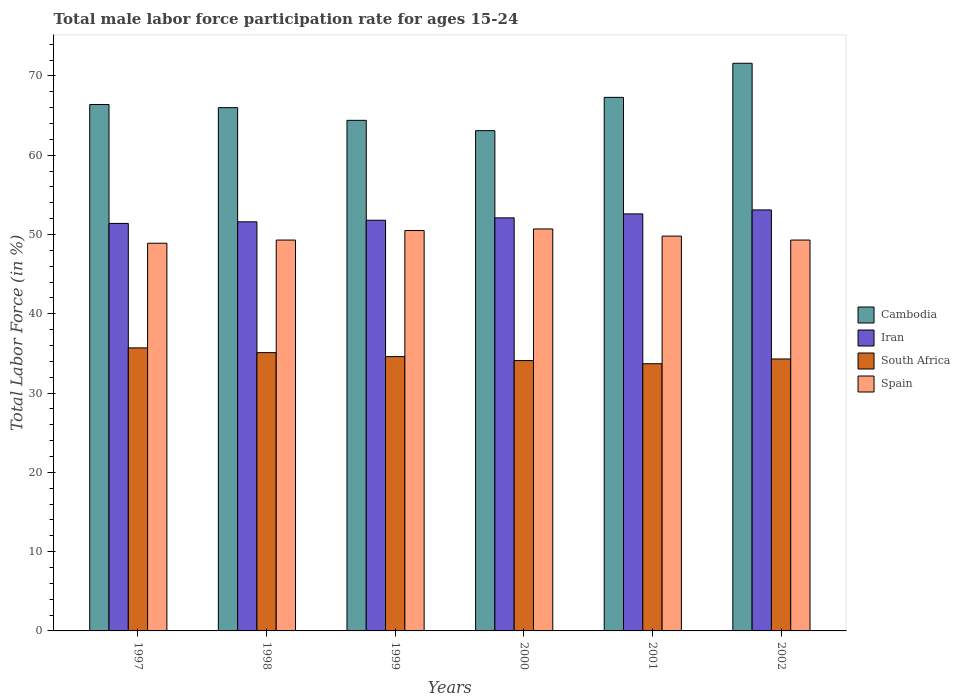How many different coloured bars are there?
Provide a short and direct response. 4. Are the number of bars on each tick of the X-axis equal?
Your answer should be very brief. Yes. How many bars are there on the 2nd tick from the left?
Your response must be concise. 4. How many bars are there on the 1st tick from the right?
Ensure brevity in your answer.  4. What is the label of the 5th group of bars from the left?
Your response must be concise. 2001. What is the male labor force participation rate in South Africa in 1997?
Your answer should be very brief. 35.7. Across all years, what is the maximum male labor force participation rate in Iran?
Provide a short and direct response. 53.1. Across all years, what is the minimum male labor force participation rate in South Africa?
Provide a short and direct response. 33.7. In which year was the male labor force participation rate in South Africa maximum?
Your response must be concise. 1997. In which year was the male labor force participation rate in Cambodia minimum?
Offer a terse response. 2000. What is the total male labor force participation rate in Spain in the graph?
Give a very brief answer. 298.5. What is the difference between the male labor force participation rate in Cambodia in 1997 and that in 2002?
Offer a very short reply. -5.2. What is the difference between the male labor force participation rate in South Africa in 2000 and the male labor force participation rate in Spain in 1998?
Make the answer very short. -15.2. What is the average male labor force participation rate in Cambodia per year?
Provide a succinct answer. 66.47. In the year 2002, what is the difference between the male labor force participation rate in South Africa and male labor force participation rate in Iran?
Your answer should be compact. -18.8. What is the ratio of the male labor force participation rate in Spain in 1999 to that in 2000?
Provide a short and direct response. 1. What is the difference between the highest and the second highest male labor force participation rate in South Africa?
Ensure brevity in your answer.  0.6. What is the difference between the highest and the lowest male labor force participation rate in Cambodia?
Give a very brief answer. 8.5. Is the sum of the male labor force participation rate in South Africa in 1998 and 2001 greater than the maximum male labor force participation rate in Spain across all years?
Offer a terse response. Yes. Is it the case that in every year, the sum of the male labor force participation rate in Spain and male labor force participation rate in Cambodia is greater than the sum of male labor force participation rate in South Africa and male labor force participation rate in Iran?
Offer a very short reply. Yes. What does the 1st bar from the left in 2001 represents?
Your response must be concise. Cambodia. What does the 2nd bar from the right in 2001 represents?
Your answer should be very brief. South Africa. Is it the case that in every year, the sum of the male labor force participation rate in Iran and male labor force participation rate in Cambodia is greater than the male labor force participation rate in Spain?
Make the answer very short. Yes. How many bars are there?
Your response must be concise. 24. How many years are there in the graph?
Ensure brevity in your answer.  6. What is the difference between two consecutive major ticks on the Y-axis?
Offer a very short reply. 10. Are the values on the major ticks of Y-axis written in scientific E-notation?
Ensure brevity in your answer.  No. Does the graph contain grids?
Ensure brevity in your answer.  No. How are the legend labels stacked?
Keep it short and to the point. Vertical. What is the title of the graph?
Provide a short and direct response. Total male labor force participation rate for ages 15-24. Does "Low income" appear as one of the legend labels in the graph?
Your answer should be compact. No. What is the Total Labor Force (in %) of Cambodia in 1997?
Give a very brief answer. 66.4. What is the Total Labor Force (in %) in Iran in 1997?
Your response must be concise. 51.4. What is the Total Labor Force (in %) of South Africa in 1997?
Offer a very short reply. 35.7. What is the Total Labor Force (in %) of Spain in 1997?
Make the answer very short. 48.9. What is the Total Labor Force (in %) of Iran in 1998?
Your response must be concise. 51.6. What is the Total Labor Force (in %) of South Africa in 1998?
Provide a short and direct response. 35.1. What is the Total Labor Force (in %) of Spain in 1998?
Your answer should be compact. 49.3. What is the Total Labor Force (in %) of Cambodia in 1999?
Provide a succinct answer. 64.4. What is the Total Labor Force (in %) of Iran in 1999?
Your answer should be very brief. 51.8. What is the Total Labor Force (in %) in South Africa in 1999?
Keep it short and to the point. 34.6. What is the Total Labor Force (in %) in Spain in 1999?
Provide a succinct answer. 50.5. What is the Total Labor Force (in %) of Cambodia in 2000?
Your answer should be compact. 63.1. What is the Total Labor Force (in %) in Iran in 2000?
Your answer should be compact. 52.1. What is the Total Labor Force (in %) of South Africa in 2000?
Ensure brevity in your answer.  34.1. What is the Total Labor Force (in %) in Spain in 2000?
Offer a very short reply. 50.7. What is the Total Labor Force (in %) in Cambodia in 2001?
Your answer should be very brief. 67.3. What is the Total Labor Force (in %) of Iran in 2001?
Your response must be concise. 52.6. What is the Total Labor Force (in %) in South Africa in 2001?
Make the answer very short. 33.7. What is the Total Labor Force (in %) of Spain in 2001?
Your answer should be compact. 49.8. What is the Total Labor Force (in %) of Cambodia in 2002?
Your response must be concise. 71.6. What is the Total Labor Force (in %) of Iran in 2002?
Keep it short and to the point. 53.1. What is the Total Labor Force (in %) in South Africa in 2002?
Make the answer very short. 34.3. What is the Total Labor Force (in %) of Spain in 2002?
Offer a terse response. 49.3. Across all years, what is the maximum Total Labor Force (in %) in Cambodia?
Your response must be concise. 71.6. Across all years, what is the maximum Total Labor Force (in %) of Iran?
Offer a terse response. 53.1. Across all years, what is the maximum Total Labor Force (in %) of South Africa?
Ensure brevity in your answer.  35.7. Across all years, what is the maximum Total Labor Force (in %) in Spain?
Give a very brief answer. 50.7. Across all years, what is the minimum Total Labor Force (in %) of Cambodia?
Ensure brevity in your answer.  63.1. Across all years, what is the minimum Total Labor Force (in %) in Iran?
Provide a short and direct response. 51.4. Across all years, what is the minimum Total Labor Force (in %) in South Africa?
Keep it short and to the point. 33.7. Across all years, what is the minimum Total Labor Force (in %) in Spain?
Ensure brevity in your answer.  48.9. What is the total Total Labor Force (in %) in Cambodia in the graph?
Your answer should be compact. 398.8. What is the total Total Labor Force (in %) in Iran in the graph?
Provide a short and direct response. 312.6. What is the total Total Labor Force (in %) in South Africa in the graph?
Offer a very short reply. 207.5. What is the total Total Labor Force (in %) of Spain in the graph?
Provide a succinct answer. 298.5. What is the difference between the Total Labor Force (in %) of Cambodia in 1997 and that in 1999?
Offer a very short reply. 2. What is the difference between the Total Labor Force (in %) of Iran in 1997 and that in 2000?
Your response must be concise. -0.7. What is the difference between the Total Labor Force (in %) of South Africa in 1997 and that in 2000?
Ensure brevity in your answer.  1.6. What is the difference between the Total Labor Force (in %) of Spain in 1997 and that in 2000?
Keep it short and to the point. -1.8. What is the difference between the Total Labor Force (in %) in Cambodia in 1997 and that in 2001?
Offer a terse response. -0.9. What is the difference between the Total Labor Force (in %) of South Africa in 1997 and that in 2001?
Your answer should be very brief. 2. What is the difference between the Total Labor Force (in %) in South Africa in 1997 and that in 2002?
Provide a short and direct response. 1.4. What is the difference between the Total Labor Force (in %) in Iran in 1998 and that in 1999?
Provide a short and direct response. -0.2. What is the difference between the Total Labor Force (in %) of South Africa in 1998 and that in 1999?
Give a very brief answer. 0.5. What is the difference between the Total Labor Force (in %) in Spain in 1998 and that in 1999?
Offer a terse response. -1.2. What is the difference between the Total Labor Force (in %) of Cambodia in 1998 and that in 2000?
Provide a short and direct response. 2.9. What is the difference between the Total Labor Force (in %) in Iran in 1998 and that in 2000?
Keep it short and to the point. -0.5. What is the difference between the Total Labor Force (in %) in Spain in 1998 and that in 2000?
Offer a very short reply. -1.4. What is the difference between the Total Labor Force (in %) in Cambodia in 1998 and that in 2001?
Your response must be concise. -1.3. What is the difference between the Total Labor Force (in %) in Cambodia in 1998 and that in 2002?
Your response must be concise. -5.6. What is the difference between the Total Labor Force (in %) in Iran in 1998 and that in 2002?
Keep it short and to the point. -1.5. What is the difference between the Total Labor Force (in %) of South Africa in 1998 and that in 2002?
Ensure brevity in your answer.  0.8. What is the difference between the Total Labor Force (in %) of Spain in 1998 and that in 2002?
Make the answer very short. 0. What is the difference between the Total Labor Force (in %) of Cambodia in 1999 and that in 2000?
Offer a very short reply. 1.3. What is the difference between the Total Labor Force (in %) of Iran in 1999 and that in 2000?
Give a very brief answer. -0.3. What is the difference between the Total Labor Force (in %) of South Africa in 1999 and that in 2000?
Provide a short and direct response. 0.5. What is the difference between the Total Labor Force (in %) of Spain in 1999 and that in 2000?
Offer a terse response. -0.2. What is the difference between the Total Labor Force (in %) of Cambodia in 1999 and that in 2001?
Keep it short and to the point. -2.9. What is the difference between the Total Labor Force (in %) of Iran in 1999 and that in 2002?
Provide a short and direct response. -1.3. What is the difference between the Total Labor Force (in %) of South Africa in 1999 and that in 2002?
Keep it short and to the point. 0.3. What is the difference between the Total Labor Force (in %) in Spain in 1999 and that in 2002?
Your response must be concise. 1.2. What is the difference between the Total Labor Force (in %) in Iran in 2000 and that in 2002?
Keep it short and to the point. -1. What is the difference between the Total Labor Force (in %) in Spain in 2000 and that in 2002?
Your answer should be very brief. 1.4. What is the difference between the Total Labor Force (in %) in Iran in 2001 and that in 2002?
Provide a succinct answer. -0.5. What is the difference between the Total Labor Force (in %) of Cambodia in 1997 and the Total Labor Force (in %) of South Africa in 1998?
Offer a very short reply. 31.3. What is the difference between the Total Labor Force (in %) in Cambodia in 1997 and the Total Labor Force (in %) in Iran in 1999?
Make the answer very short. 14.6. What is the difference between the Total Labor Force (in %) of Cambodia in 1997 and the Total Labor Force (in %) of South Africa in 1999?
Your answer should be compact. 31.8. What is the difference between the Total Labor Force (in %) of Iran in 1997 and the Total Labor Force (in %) of Spain in 1999?
Keep it short and to the point. 0.9. What is the difference between the Total Labor Force (in %) in South Africa in 1997 and the Total Labor Force (in %) in Spain in 1999?
Your response must be concise. -14.8. What is the difference between the Total Labor Force (in %) of Cambodia in 1997 and the Total Labor Force (in %) of South Africa in 2000?
Give a very brief answer. 32.3. What is the difference between the Total Labor Force (in %) in Cambodia in 1997 and the Total Labor Force (in %) in Spain in 2000?
Ensure brevity in your answer.  15.7. What is the difference between the Total Labor Force (in %) of Iran in 1997 and the Total Labor Force (in %) of South Africa in 2000?
Your answer should be very brief. 17.3. What is the difference between the Total Labor Force (in %) of South Africa in 1997 and the Total Labor Force (in %) of Spain in 2000?
Give a very brief answer. -15. What is the difference between the Total Labor Force (in %) in Cambodia in 1997 and the Total Labor Force (in %) in Iran in 2001?
Your answer should be very brief. 13.8. What is the difference between the Total Labor Force (in %) in Cambodia in 1997 and the Total Labor Force (in %) in South Africa in 2001?
Provide a succinct answer. 32.7. What is the difference between the Total Labor Force (in %) in Cambodia in 1997 and the Total Labor Force (in %) in Spain in 2001?
Your answer should be very brief. 16.6. What is the difference between the Total Labor Force (in %) of Iran in 1997 and the Total Labor Force (in %) of South Africa in 2001?
Your answer should be compact. 17.7. What is the difference between the Total Labor Force (in %) of Iran in 1997 and the Total Labor Force (in %) of Spain in 2001?
Provide a short and direct response. 1.6. What is the difference between the Total Labor Force (in %) of South Africa in 1997 and the Total Labor Force (in %) of Spain in 2001?
Your response must be concise. -14.1. What is the difference between the Total Labor Force (in %) in Cambodia in 1997 and the Total Labor Force (in %) in South Africa in 2002?
Ensure brevity in your answer.  32.1. What is the difference between the Total Labor Force (in %) in Cambodia in 1997 and the Total Labor Force (in %) in Spain in 2002?
Make the answer very short. 17.1. What is the difference between the Total Labor Force (in %) of South Africa in 1997 and the Total Labor Force (in %) of Spain in 2002?
Provide a succinct answer. -13.6. What is the difference between the Total Labor Force (in %) in Cambodia in 1998 and the Total Labor Force (in %) in Iran in 1999?
Offer a very short reply. 14.2. What is the difference between the Total Labor Force (in %) in Cambodia in 1998 and the Total Labor Force (in %) in South Africa in 1999?
Ensure brevity in your answer.  31.4. What is the difference between the Total Labor Force (in %) of Cambodia in 1998 and the Total Labor Force (in %) of Spain in 1999?
Your answer should be compact. 15.5. What is the difference between the Total Labor Force (in %) in Iran in 1998 and the Total Labor Force (in %) in South Africa in 1999?
Your answer should be compact. 17. What is the difference between the Total Labor Force (in %) of South Africa in 1998 and the Total Labor Force (in %) of Spain in 1999?
Make the answer very short. -15.4. What is the difference between the Total Labor Force (in %) in Cambodia in 1998 and the Total Labor Force (in %) in South Africa in 2000?
Provide a succinct answer. 31.9. What is the difference between the Total Labor Force (in %) in Cambodia in 1998 and the Total Labor Force (in %) in Spain in 2000?
Make the answer very short. 15.3. What is the difference between the Total Labor Force (in %) of South Africa in 1998 and the Total Labor Force (in %) of Spain in 2000?
Your response must be concise. -15.6. What is the difference between the Total Labor Force (in %) in Cambodia in 1998 and the Total Labor Force (in %) in Iran in 2001?
Provide a succinct answer. 13.4. What is the difference between the Total Labor Force (in %) in Cambodia in 1998 and the Total Labor Force (in %) in South Africa in 2001?
Offer a very short reply. 32.3. What is the difference between the Total Labor Force (in %) of Cambodia in 1998 and the Total Labor Force (in %) of Spain in 2001?
Give a very brief answer. 16.2. What is the difference between the Total Labor Force (in %) in Iran in 1998 and the Total Labor Force (in %) in Spain in 2001?
Your answer should be very brief. 1.8. What is the difference between the Total Labor Force (in %) in South Africa in 1998 and the Total Labor Force (in %) in Spain in 2001?
Keep it short and to the point. -14.7. What is the difference between the Total Labor Force (in %) in Cambodia in 1998 and the Total Labor Force (in %) in South Africa in 2002?
Your answer should be compact. 31.7. What is the difference between the Total Labor Force (in %) of Cambodia in 1998 and the Total Labor Force (in %) of Spain in 2002?
Make the answer very short. 16.7. What is the difference between the Total Labor Force (in %) in Iran in 1998 and the Total Labor Force (in %) in Spain in 2002?
Keep it short and to the point. 2.3. What is the difference between the Total Labor Force (in %) in South Africa in 1998 and the Total Labor Force (in %) in Spain in 2002?
Keep it short and to the point. -14.2. What is the difference between the Total Labor Force (in %) of Cambodia in 1999 and the Total Labor Force (in %) of Iran in 2000?
Keep it short and to the point. 12.3. What is the difference between the Total Labor Force (in %) of Cambodia in 1999 and the Total Labor Force (in %) of South Africa in 2000?
Keep it short and to the point. 30.3. What is the difference between the Total Labor Force (in %) in Iran in 1999 and the Total Labor Force (in %) in South Africa in 2000?
Keep it short and to the point. 17.7. What is the difference between the Total Labor Force (in %) in Iran in 1999 and the Total Labor Force (in %) in Spain in 2000?
Ensure brevity in your answer.  1.1. What is the difference between the Total Labor Force (in %) in South Africa in 1999 and the Total Labor Force (in %) in Spain in 2000?
Ensure brevity in your answer.  -16.1. What is the difference between the Total Labor Force (in %) in Cambodia in 1999 and the Total Labor Force (in %) in Iran in 2001?
Offer a very short reply. 11.8. What is the difference between the Total Labor Force (in %) of Cambodia in 1999 and the Total Labor Force (in %) of South Africa in 2001?
Ensure brevity in your answer.  30.7. What is the difference between the Total Labor Force (in %) of Iran in 1999 and the Total Labor Force (in %) of Spain in 2001?
Provide a succinct answer. 2. What is the difference between the Total Labor Force (in %) of South Africa in 1999 and the Total Labor Force (in %) of Spain in 2001?
Offer a terse response. -15.2. What is the difference between the Total Labor Force (in %) in Cambodia in 1999 and the Total Labor Force (in %) in Iran in 2002?
Offer a terse response. 11.3. What is the difference between the Total Labor Force (in %) of Cambodia in 1999 and the Total Labor Force (in %) of South Africa in 2002?
Your answer should be compact. 30.1. What is the difference between the Total Labor Force (in %) of Iran in 1999 and the Total Labor Force (in %) of Spain in 2002?
Offer a terse response. 2.5. What is the difference between the Total Labor Force (in %) in South Africa in 1999 and the Total Labor Force (in %) in Spain in 2002?
Offer a terse response. -14.7. What is the difference between the Total Labor Force (in %) in Cambodia in 2000 and the Total Labor Force (in %) in Iran in 2001?
Ensure brevity in your answer.  10.5. What is the difference between the Total Labor Force (in %) of Cambodia in 2000 and the Total Labor Force (in %) of South Africa in 2001?
Offer a terse response. 29.4. What is the difference between the Total Labor Force (in %) of Iran in 2000 and the Total Labor Force (in %) of South Africa in 2001?
Ensure brevity in your answer.  18.4. What is the difference between the Total Labor Force (in %) of Iran in 2000 and the Total Labor Force (in %) of Spain in 2001?
Offer a very short reply. 2.3. What is the difference between the Total Labor Force (in %) of South Africa in 2000 and the Total Labor Force (in %) of Spain in 2001?
Offer a terse response. -15.7. What is the difference between the Total Labor Force (in %) in Cambodia in 2000 and the Total Labor Force (in %) in Iran in 2002?
Keep it short and to the point. 10. What is the difference between the Total Labor Force (in %) of Cambodia in 2000 and the Total Labor Force (in %) of South Africa in 2002?
Give a very brief answer. 28.8. What is the difference between the Total Labor Force (in %) of Cambodia in 2000 and the Total Labor Force (in %) of Spain in 2002?
Provide a succinct answer. 13.8. What is the difference between the Total Labor Force (in %) in South Africa in 2000 and the Total Labor Force (in %) in Spain in 2002?
Your response must be concise. -15.2. What is the difference between the Total Labor Force (in %) in Cambodia in 2001 and the Total Labor Force (in %) in South Africa in 2002?
Provide a short and direct response. 33. What is the difference between the Total Labor Force (in %) of South Africa in 2001 and the Total Labor Force (in %) of Spain in 2002?
Provide a succinct answer. -15.6. What is the average Total Labor Force (in %) in Cambodia per year?
Provide a short and direct response. 66.47. What is the average Total Labor Force (in %) of Iran per year?
Ensure brevity in your answer.  52.1. What is the average Total Labor Force (in %) of South Africa per year?
Your answer should be compact. 34.58. What is the average Total Labor Force (in %) of Spain per year?
Provide a succinct answer. 49.75. In the year 1997, what is the difference between the Total Labor Force (in %) in Cambodia and Total Labor Force (in %) in Iran?
Keep it short and to the point. 15. In the year 1997, what is the difference between the Total Labor Force (in %) in Cambodia and Total Labor Force (in %) in South Africa?
Provide a short and direct response. 30.7. In the year 1998, what is the difference between the Total Labor Force (in %) in Cambodia and Total Labor Force (in %) in South Africa?
Your response must be concise. 30.9. In the year 1998, what is the difference between the Total Labor Force (in %) in Iran and Total Labor Force (in %) in South Africa?
Give a very brief answer. 16.5. In the year 1999, what is the difference between the Total Labor Force (in %) in Cambodia and Total Labor Force (in %) in Iran?
Provide a succinct answer. 12.6. In the year 1999, what is the difference between the Total Labor Force (in %) of Cambodia and Total Labor Force (in %) of South Africa?
Give a very brief answer. 29.8. In the year 1999, what is the difference between the Total Labor Force (in %) of South Africa and Total Labor Force (in %) of Spain?
Provide a succinct answer. -15.9. In the year 2000, what is the difference between the Total Labor Force (in %) in Cambodia and Total Labor Force (in %) in South Africa?
Your answer should be very brief. 29. In the year 2000, what is the difference between the Total Labor Force (in %) in Cambodia and Total Labor Force (in %) in Spain?
Your response must be concise. 12.4. In the year 2000, what is the difference between the Total Labor Force (in %) of Iran and Total Labor Force (in %) of South Africa?
Provide a short and direct response. 18. In the year 2000, what is the difference between the Total Labor Force (in %) of Iran and Total Labor Force (in %) of Spain?
Provide a succinct answer. 1.4. In the year 2000, what is the difference between the Total Labor Force (in %) in South Africa and Total Labor Force (in %) in Spain?
Your answer should be very brief. -16.6. In the year 2001, what is the difference between the Total Labor Force (in %) of Cambodia and Total Labor Force (in %) of South Africa?
Keep it short and to the point. 33.6. In the year 2001, what is the difference between the Total Labor Force (in %) in Iran and Total Labor Force (in %) in South Africa?
Your answer should be compact. 18.9. In the year 2001, what is the difference between the Total Labor Force (in %) of Iran and Total Labor Force (in %) of Spain?
Your response must be concise. 2.8. In the year 2001, what is the difference between the Total Labor Force (in %) in South Africa and Total Labor Force (in %) in Spain?
Provide a short and direct response. -16.1. In the year 2002, what is the difference between the Total Labor Force (in %) in Cambodia and Total Labor Force (in %) in Iran?
Give a very brief answer. 18.5. In the year 2002, what is the difference between the Total Labor Force (in %) of Cambodia and Total Labor Force (in %) of South Africa?
Make the answer very short. 37.3. In the year 2002, what is the difference between the Total Labor Force (in %) of Cambodia and Total Labor Force (in %) of Spain?
Make the answer very short. 22.3. In the year 2002, what is the difference between the Total Labor Force (in %) of Iran and Total Labor Force (in %) of South Africa?
Give a very brief answer. 18.8. In the year 2002, what is the difference between the Total Labor Force (in %) in Iran and Total Labor Force (in %) in Spain?
Provide a succinct answer. 3.8. In the year 2002, what is the difference between the Total Labor Force (in %) of South Africa and Total Labor Force (in %) of Spain?
Your answer should be very brief. -15. What is the ratio of the Total Labor Force (in %) of Iran in 1997 to that in 1998?
Your answer should be compact. 1. What is the ratio of the Total Labor Force (in %) of South Africa in 1997 to that in 1998?
Offer a terse response. 1.02. What is the ratio of the Total Labor Force (in %) in Cambodia in 1997 to that in 1999?
Ensure brevity in your answer.  1.03. What is the ratio of the Total Labor Force (in %) in Iran in 1997 to that in 1999?
Give a very brief answer. 0.99. What is the ratio of the Total Labor Force (in %) in South Africa in 1997 to that in 1999?
Provide a short and direct response. 1.03. What is the ratio of the Total Labor Force (in %) in Spain in 1997 to that in 1999?
Give a very brief answer. 0.97. What is the ratio of the Total Labor Force (in %) in Cambodia in 1997 to that in 2000?
Your response must be concise. 1.05. What is the ratio of the Total Labor Force (in %) in Iran in 1997 to that in 2000?
Ensure brevity in your answer.  0.99. What is the ratio of the Total Labor Force (in %) of South Africa in 1997 to that in 2000?
Offer a terse response. 1.05. What is the ratio of the Total Labor Force (in %) in Spain in 1997 to that in 2000?
Provide a succinct answer. 0.96. What is the ratio of the Total Labor Force (in %) in Cambodia in 1997 to that in 2001?
Keep it short and to the point. 0.99. What is the ratio of the Total Labor Force (in %) in Iran in 1997 to that in 2001?
Your answer should be compact. 0.98. What is the ratio of the Total Labor Force (in %) in South Africa in 1997 to that in 2001?
Offer a very short reply. 1.06. What is the ratio of the Total Labor Force (in %) in Spain in 1997 to that in 2001?
Offer a terse response. 0.98. What is the ratio of the Total Labor Force (in %) of Cambodia in 1997 to that in 2002?
Ensure brevity in your answer.  0.93. What is the ratio of the Total Labor Force (in %) of Iran in 1997 to that in 2002?
Keep it short and to the point. 0.97. What is the ratio of the Total Labor Force (in %) in South Africa in 1997 to that in 2002?
Provide a short and direct response. 1.04. What is the ratio of the Total Labor Force (in %) in Cambodia in 1998 to that in 1999?
Your answer should be very brief. 1.02. What is the ratio of the Total Labor Force (in %) in South Africa in 1998 to that in 1999?
Your answer should be compact. 1.01. What is the ratio of the Total Labor Force (in %) of Spain in 1998 to that in 1999?
Make the answer very short. 0.98. What is the ratio of the Total Labor Force (in %) in Cambodia in 1998 to that in 2000?
Your answer should be compact. 1.05. What is the ratio of the Total Labor Force (in %) of Iran in 1998 to that in 2000?
Offer a very short reply. 0.99. What is the ratio of the Total Labor Force (in %) in South Africa in 1998 to that in 2000?
Make the answer very short. 1.03. What is the ratio of the Total Labor Force (in %) in Spain in 1998 to that in 2000?
Offer a very short reply. 0.97. What is the ratio of the Total Labor Force (in %) in Cambodia in 1998 to that in 2001?
Offer a terse response. 0.98. What is the ratio of the Total Labor Force (in %) of Iran in 1998 to that in 2001?
Ensure brevity in your answer.  0.98. What is the ratio of the Total Labor Force (in %) in South Africa in 1998 to that in 2001?
Give a very brief answer. 1.04. What is the ratio of the Total Labor Force (in %) of Spain in 1998 to that in 2001?
Ensure brevity in your answer.  0.99. What is the ratio of the Total Labor Force (in %) of Cambodia in 1998 to that in 2002?
Make the answer very short. 0.92. What is the ratio of the Total Labor Force (in %) of Iran in 1998 to that in 2002?
Offer a terse response. 0.97. What is the ratio of the Total Labor Force (in %) of South Africa in 1998 to that in 2002?
Give a very brief answer. 1.02. What is the ratio of the Total Labor Force (in %) of Spain in 1998 to that in 2002?
Provide a short and direct response. 1. What is the ratio of the Total Labor Force (in %) in Cambodia in 1999 to that in 2000?
Offer a terse response. 1.02. What is the ratio of the Total Labor Force (in %) of Iran in 1999 to that in 2000?
Give a very brief answer. 0.99. What is the ratio of the Total Labor Force (in %) of South Africa in 1999 to that in 2000?
Provide a succinct answer. 1.01. What is the ratio of the Total Labor Force (in %) in Cambodia in 1999 to that in 2001?
Ensure brevity in your answer.  0.96. What is the ratio of the Total Labor Force (in %) of Iran in 1999 to that in 2001?
Ensure brevity in your answer.  0.98. What is the ratio of the Total Labor Force (in %) in South Africa in 1999 to that in 2001?
Ensure brevity in your answer.  1.03. What is the ratio of the Total Labor Force (in %) in Spain in 1999 to that in 2001?
Provide a short and direct response. 1.01. What is the ratio of the Total Labor Force (in %) of Cambodia in 1999 to that in 2002?
Provide a succinct answer. 0.9. What is the ratio of the Total Labor Force (in %) in Iran in 1999 to that in 2002?
Provide a short and direct response. 0.98. What is the ratio of the Total Labor Force (in %) in South Africa in 1999 to that in 2002?
Your response must be concise. 1.01. What is the ratio of the Total Labor Force (in %) of Spain in 1999 to that in 2002?
Give a very brief answer. 1.02. What is the ratio of the Total Labor Force (in %) of Cambodia in 2000 to that in 2001?
Provide a short and direct response. 0.94. What is the ratio of the Total Labor Force (in %) of Iran in 2000 to that in 2001?
Offer a very short reply. 0.99. What is the ratio of the Total Labor Force (in %) of South Africa in 2000 to that in 2001?
Give a very brief answer. 1.01. What is the ratio of the Total Labor Force (in %) of Spain in 2000 to that in 2001?
Offer a very short reply. 1.02. What is the ratio of the Total Labor Force (in %) of Cambodia in 2000 to that in 2002?
Offer a terse response. 0.88. What is the ratio of the Total Labor Force (in %) of Iran in 2000 to that in 2002?
Make the answer very short. 0.98. What is the ratio of the Total Labor Force (in %) in South Africa in 2000 to that in 2002?
Offer a very short reply. 0.99. What is the ratio of the Total Labor Force (in %) in Spain in 2000 to that in 2002?
Your response must be concise. 1.03. What is the ratio of the Total Labor Force (in %) of Cambodia in 2001 to that in 2002?
Provide a succinct answer. 0.94. What is the ratio of the Total Labor Force (in %) of Iran in 2001 to that in 2002?
Make the answer very short. 0.99. What is the ratio of the Total Labor Force (in %) of South Africa in 2001 to that in 2002?
Your response must be concise. 0.98. What is the difference between the highest and the second highest Total Labor Force (in %) in Cambodia?
Keep it short and to the point. 4.3. What is the difference between the highest and the second highest Total Labor Force (in %) in Iran?
Provide a succinct answer. 0.5. What is the difference between the highest and the lowest Total Labor Force (in %) of South Africa?
Your answer should be compact. 2. 